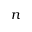Convert formula to latex. <formula><loc_0><loc_0><loc_500><loc_500>n</formula> 